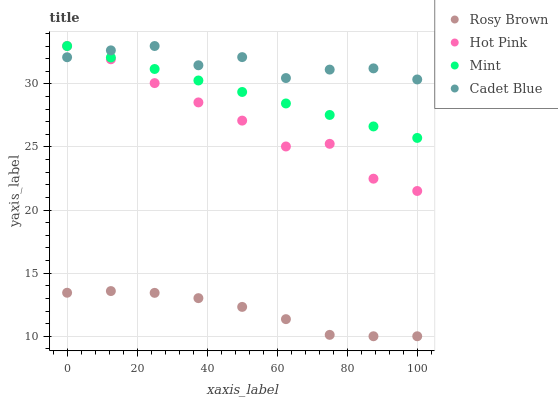Does Rosy Brown have the minimum area under the curve?
Answer yes or no. Yes. Does Cadet Blue have the maximum area under the curve?
Answer yes or no. Yes. Does Mint have the minimum area under the curve?
Answer yes or no. No. Does Mint have the maximum area under the curve?
Answer yes or no. No. Is Mint the smoothest?
Answer yes or no. Yes. Is Cadet Blue the roughest?
Answer yes or no. Yes. Is Rosy Brown the smoothest?
Answer yes or no. No. Is Rosy Brown the roughest?
Answer yes or no. No. Does Rosy Brown have the lowest value?
Answer yes or no. Yes. Does Mint have the lowest value?
Answer yes or no. No. Does Hot Pink have the highest value?
Answer yes or no. Yes. Does Rosy Brown have the highest value?
Answer yes or no. No. Is Rosy Brown less than Cadet Blue?
Answer yes or no. Yes. Is Hot Pink greater than Rosy Brown?
Answer yes or no. Yes. Does Hot Pink intersect Mint?
Answer yes or no. Yes. Is Hot Pink less than Mint?
Answer yes or no. No. Is Hot Pink greater than Mint?
Answer yes or no. No. Does Rosy Brown intersect Cadet Blue?
Answer yes or no. No. 